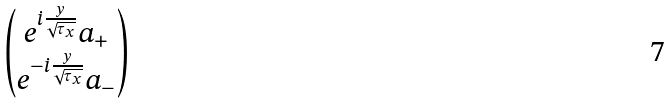Convert formula to latex. <formula><loc_0><loc_0><loc_500><loc_500>\begin{pmatrix} e ^ { i \frac { y } { \sqrt { \tau _ { x } } } } a _ { + } \\ e ^ { - i \frac { y } { \sqrt { \tau _ { x } } } } a _ { - } \end{pmatrix}</formula> 